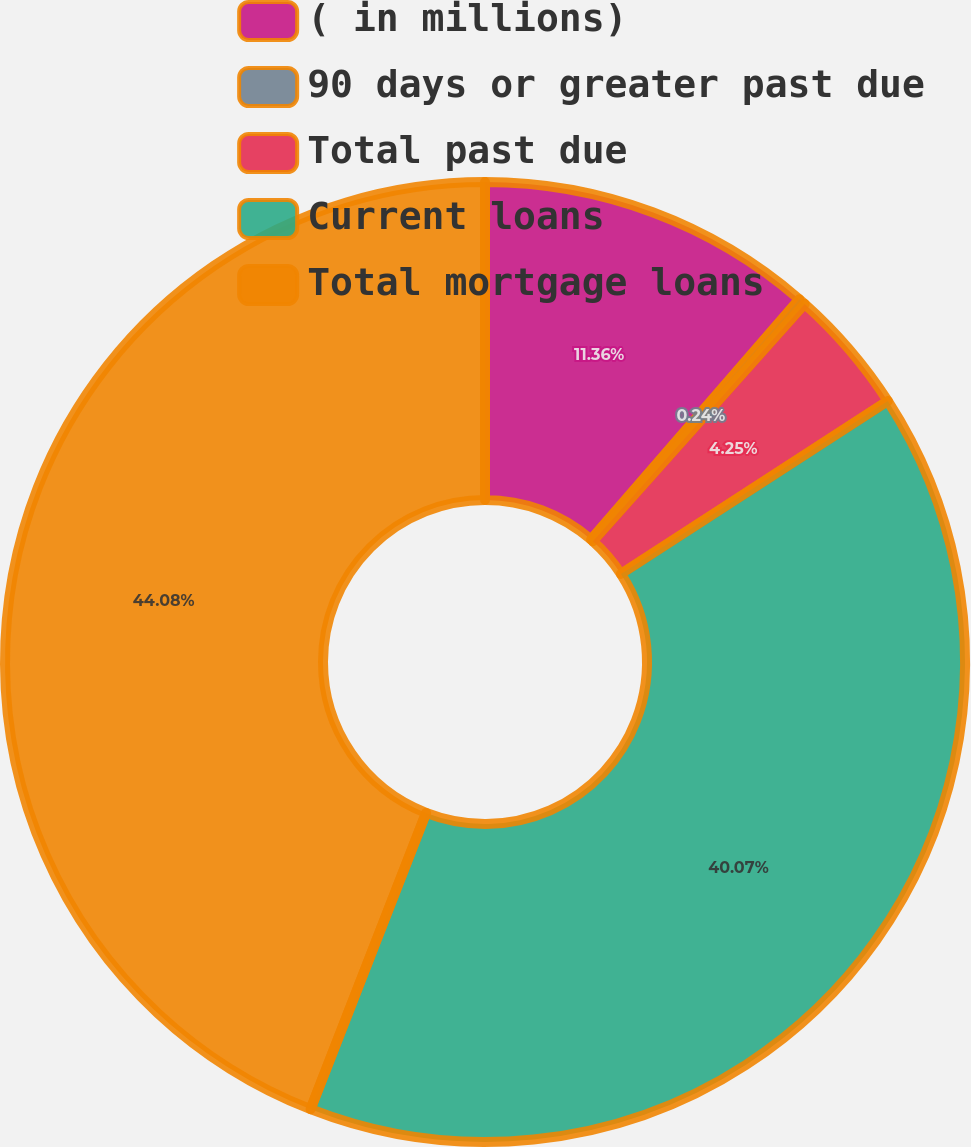Convert chart to OTSL. <chart><loc_0><loc_0><loc_500><loc_500><pie_chart><fcel>( in millions)<fcel>90 days or greater past due<fcel>Total past due<fcel>Current loans<fcel>Total mortgage loans<nl><fcel>11.36%<fcel>0.24%<fcel>4.25%<fcel>40.07%<fcel>44.08%<nl></chart> 